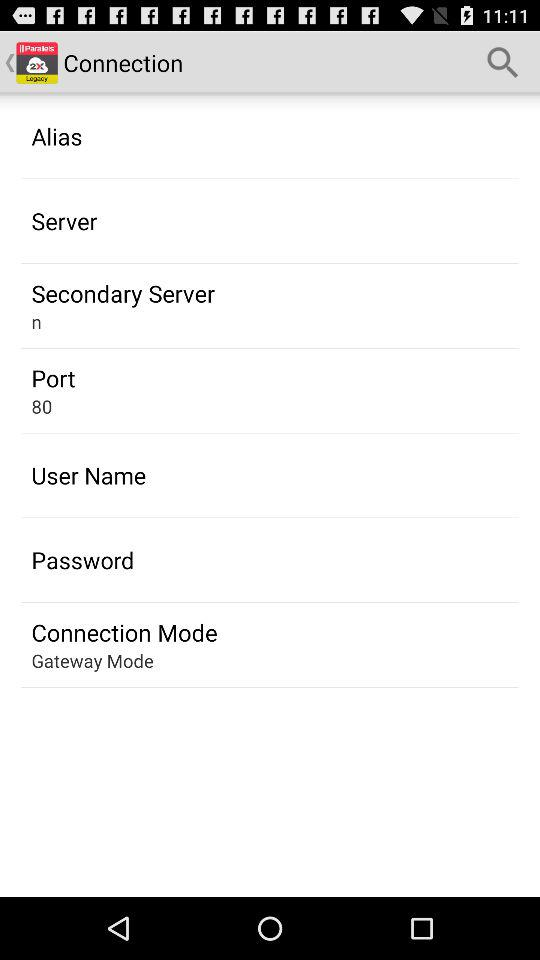What is the name of the secondary server? The name of the secondary server is "n". 